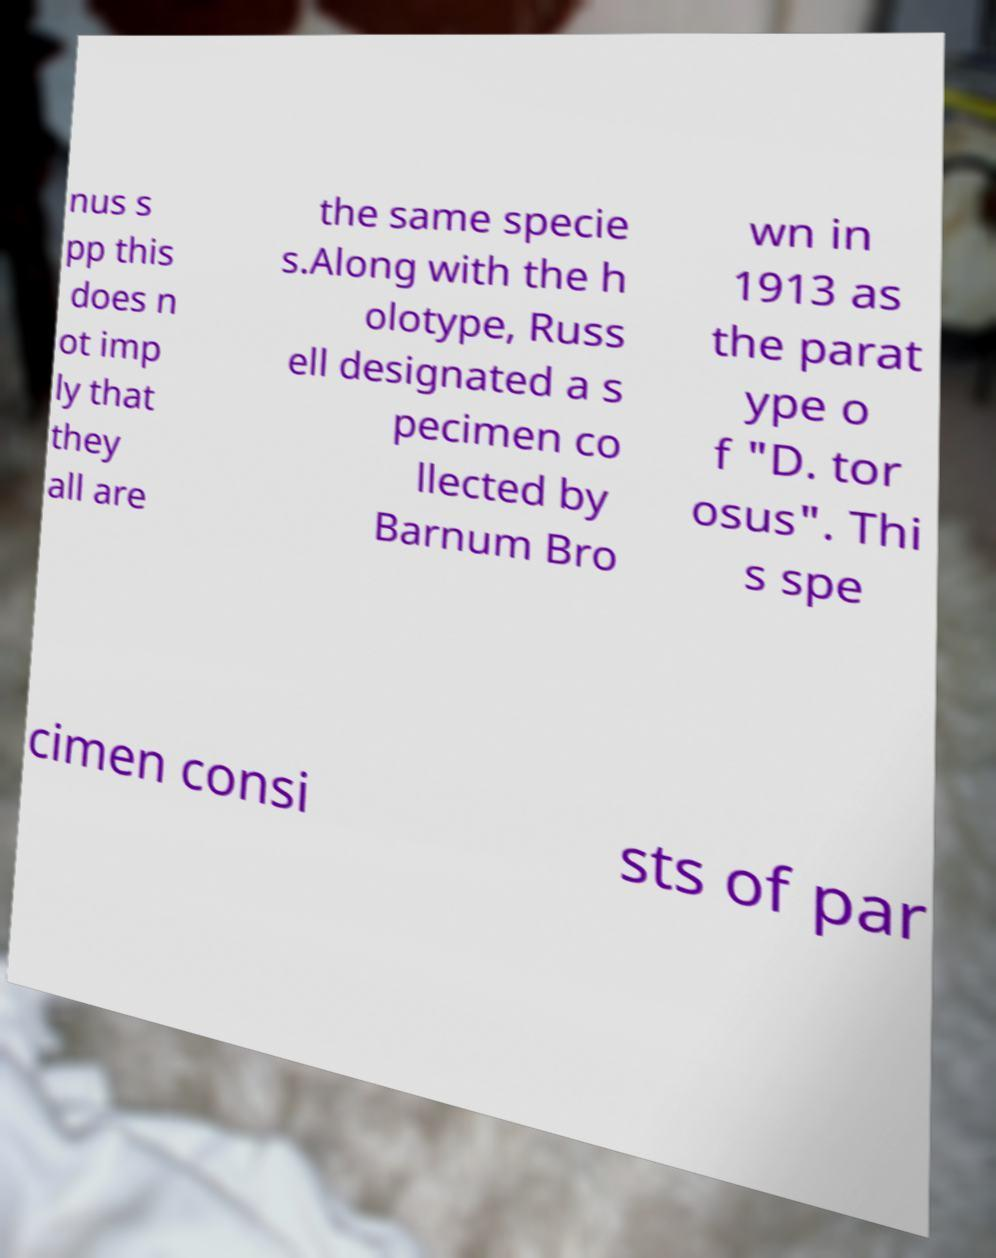Can you read and provide the text displayed in the image?This photo seems to have some interesting text. Can you extract and type it out for me? nus s pp this does n ot imp ly that they all are the same specie s.Along with the h olotype, Russ ell designated a s pecimen co llected by Barnum Bro wn in 1913 as the parat ype o f "D. tor osus". Thi s spe cimen consi sts of par 